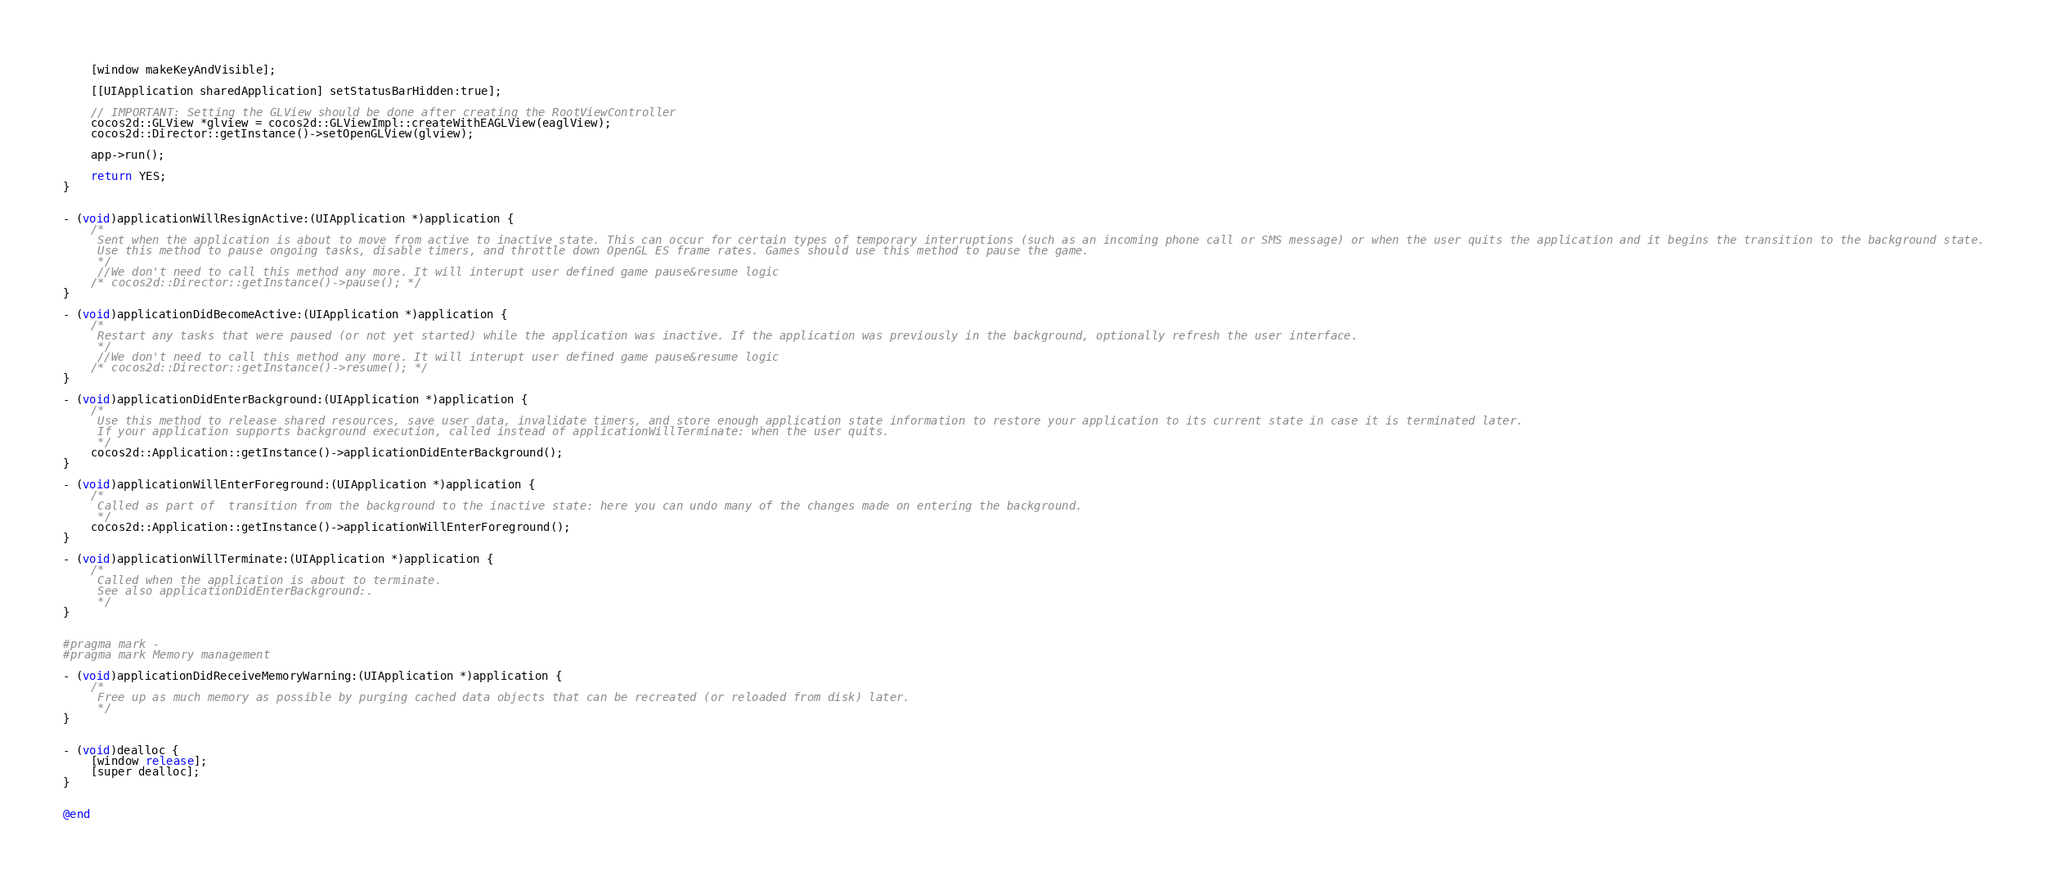<code> <loc_0><loc_0><loc_500><loc_500><_ObjectiveC_>    [window makeKeyAndVisible];

    [[UIApplication sharedApplication] setStatusBarHidden:true];

    // IMPORTANT: Setting the GLView should be done after creating the RootViewController
    cocos2d::GLView *glview = cocos2d::GLViewImpl::createWithEAGLView(eaglView);
    cocos2d::Director::getInstance()->setOpenGLView(glview);

    app->run();

    return YES;
}


- (void)applicationWillResignActive:(UIApplication *)application {
    /*
     Sent when the application is about to move from active to inactive state. This can occur for certain types of temporary interruptions (such as an incoming phone call or SMS message) or when the user quits the application and it begins the transition to the background state.
     Use this method to pause ongoing tasks, disable timers, and throttle down OpenGL ES frame rates. Games should use this method to pause the game.
     */
     //We don't need to call this method any more. It will interupt user defined game pause&resume logic
    /* cocos2d::Director::getInstance()->pause(); */
}

- (void)applicationDidBecomeActive:(UIApplication *)application {
    /*
     Restart any tasks that were paused (or not yet started) while the application was inactive. If the application was previously in the background, optionally refresh the user interface.
     */
     //We don't need to call this method any more. It will interupt user defined game pause&resume logic
    /* cocos2d::Director::getInstance()->resume(); */
}

- (void)applicationDidEnterBackground:(UIApplication *)application {
    /*
     Use this method to release shared resources, save user data, invalidate timers, and store enough application state information to restore your application to its current state in case it is terminated later. 
     If your application supports background execution, called instead of applicationWillTerminate: when the user quits.
     */
    cocos2d::Application::getInstance()->applicationDidEnterBackground();
}

- (void)applicationWillEnterForeground:(UIApplication *)application {
    /*
     Called as part of  transition from the background to the inactive state: here you can undo many of the changes made on entering the background.
     */
    cocos2d::Application::getInstance()->applicationWillEnterForeground();
}

- (void)applicationWillTerminate:(UIApplication *)application {
    /*
     Called when the application is about to terminate.
     See also applicationDidEnterBackground:.
     */
}


#pragma mark -
#pragma mark Memory management

- (void)applicationDidReceiveMemoryWarning:(UIApplication *)application {
    /*
     Free up as much memory as possible by purging cached data objects that can be recreated (or reloaded from disk) later.
     */
}


- (void)dealloc {
    [window release];
    [super dealloc];
}


@end
</code> 